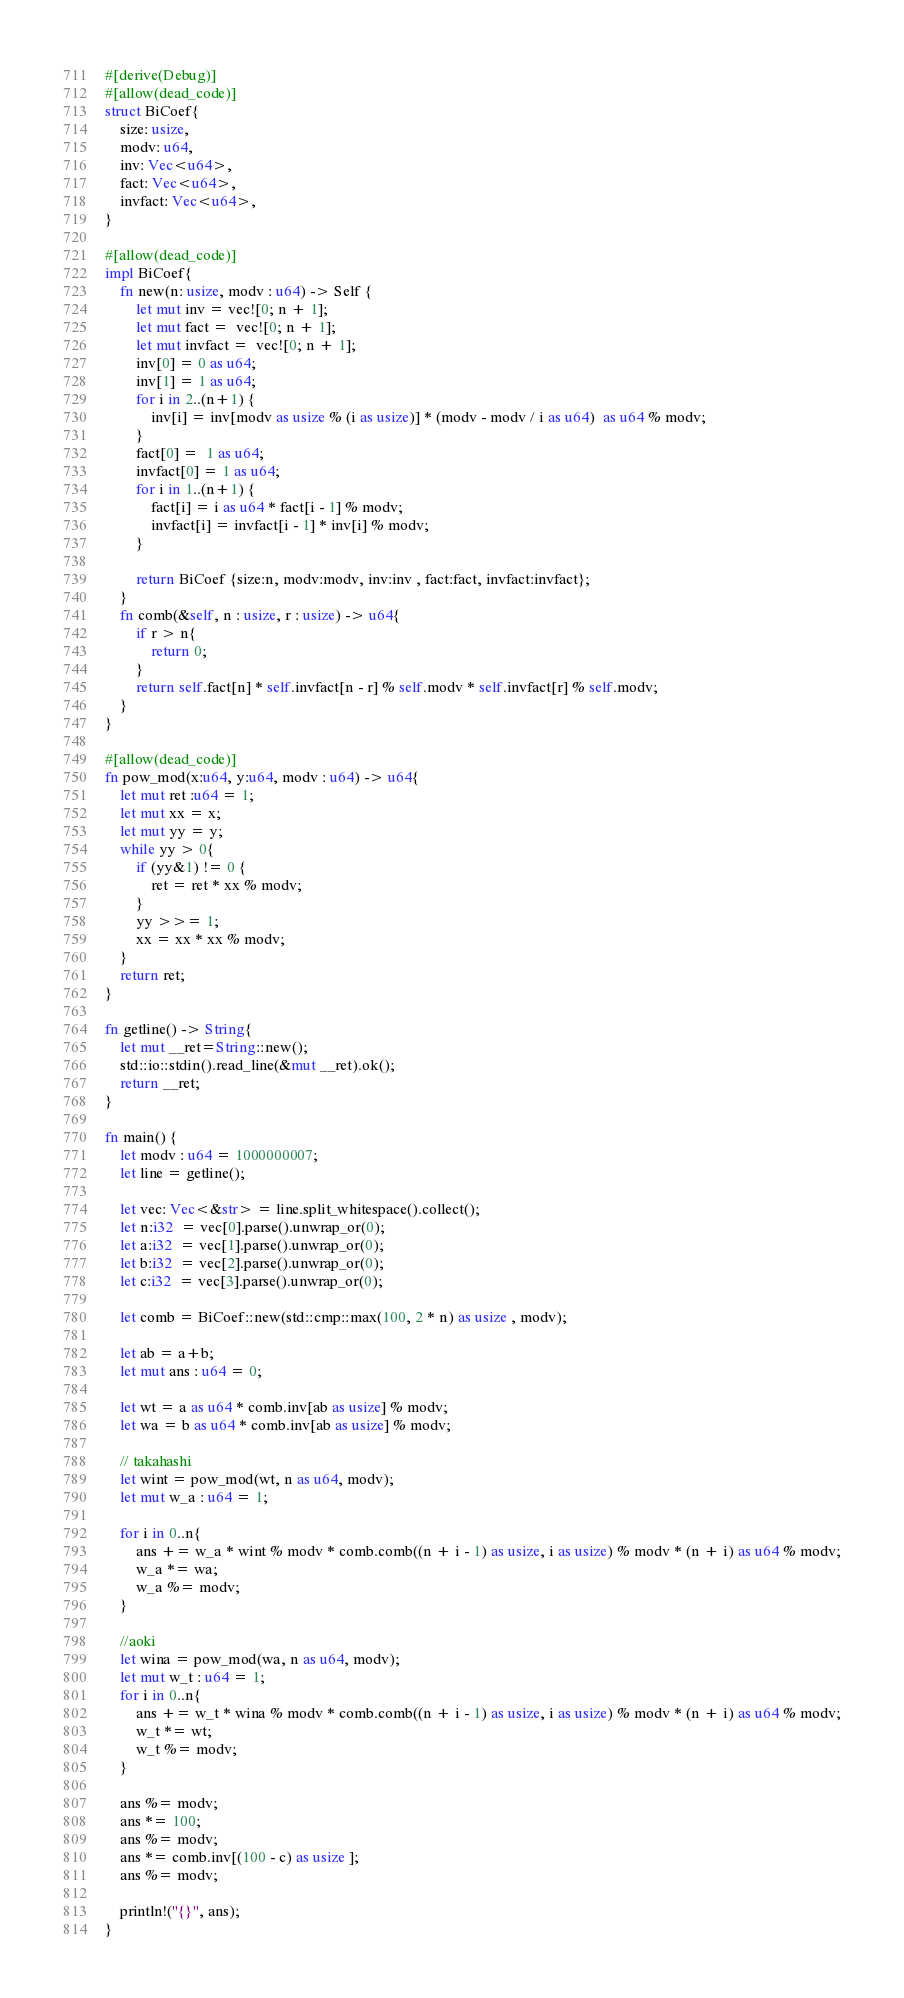Convert code to text. <code><loc_0><loc_0><loc_500><loc_500><_Rust_>#[derive(Debug)]
#[allow(dead_code)]
struct BiCoef{
    size: usize,
    modv: u64,
    inv: Vec<u64>,
    fact: Vec<u64>,
    invfact: Vec<u64>,
}

#[allow(dead_code)]
impl BiCoef{
    fn new(n: usize, modv : u64) -> Self {
        let mut inv = vec![0; n + 1];
        let mut fact =  vec![0; n + 1];
        let mut invfact =  vec![0; n + 1];
        inv[0] = 0 as u64;
        inv[1] = 1 as u64;
        for i in 2..(n+1) {
            inv[i] = inv[modv as usize % (i as usize)] * (modv - modv / i as u64)  as u64 % modv;
        }
        fact[0] =  1 as u64;
        invfact[0] = 1 as u64;
        for i in 1..(n+1) {
            fact[i] = i as u64 * fact[i - 1] % modv;
            invfact[i] = invfact[i - 1] * inv[i] % modv;
        }

        return BiCoef {size:n, modv:modv, inv:inv , fact:fact, invfact:invfact};
    }
    fn comb(&self, n : usize, r : usize) -> u64{
        if r > n{
            return 0;
        }
        return self.fact[n] * self.invfact[n - r] % self.modv * self.invfact[r] % self.modv;
    }
}

#[allow(dead_code)]
fn pow_mod(x:u64, y:u64, modv : u64) -> u64{
    let mut ret :u64 = 1;
    let mut xx = x;
    let mut yy = y;
    while yy > 0{
        if (yy&1) != 0 {
            ret = ret * xx % modv;
        }
        yy >>= 1;
        xx = xx * xx % modv;
    }
    return ret;
}

fn getline() -> String{
	let mut __ret=String::new();
	std::io::stdin().read_line(&mut __ret).ok();
	return __ret;
}

fn main() {
    let modv : u64 = 1000000007;
    let line = getline();

    let vec: Vec<&str> = line.split_whitespace().collect();
    let n:i32  = vec[0].parse().unwrap_or(0);
    let a:i32  = vec[1].parse().unwrap_or(0);
    let b:i32  = vec[2].parse().unwrap_or(0);
    let c:i32  = vec[3].parse().unwrap_or(0);
    
    let comb = BiCoef::new(std::cmp::max(100, 2 * n) as usize , modv);

    let ab = a+b;
    let mut ans : u64 = 0;

    let wt = a as u64 * comb.inv[ab as usize] % modv;
    let wa = b as u64 * comb.inv[ab as usize] % modv;

    // takahashi
    let wint = pow_mod(wt, n as u64, modv);
    let mut w_a : u64 = 1;

    for i in 0..n{
        ans += w_a * wint % modv * comb.comb((n + i - 1) as usize, i as usize) % modv * (n + i) as u64 % modv;
        w_a *= wa;
        w_a %= modv;
    }

    //aoki
    let wina = pow_mod(wa, n as u64, modv);
    let mut w_t : u64 = 1;    
    for i in 0..n{
        ans += w_t * wina % modv * comb.comb((n + i - 1) as usize, i as usize) % modv * (n + i) as u64 % modv;
        w_t *= wt;
        w_t %= modv;
    }

    ans %= modv;
    ans *= 100;
    ans %= modv;
    ans *= comb.inv[(100 - c) as usize ];
    ans %= modv;

    println!("{}", ans);
}
</code> 